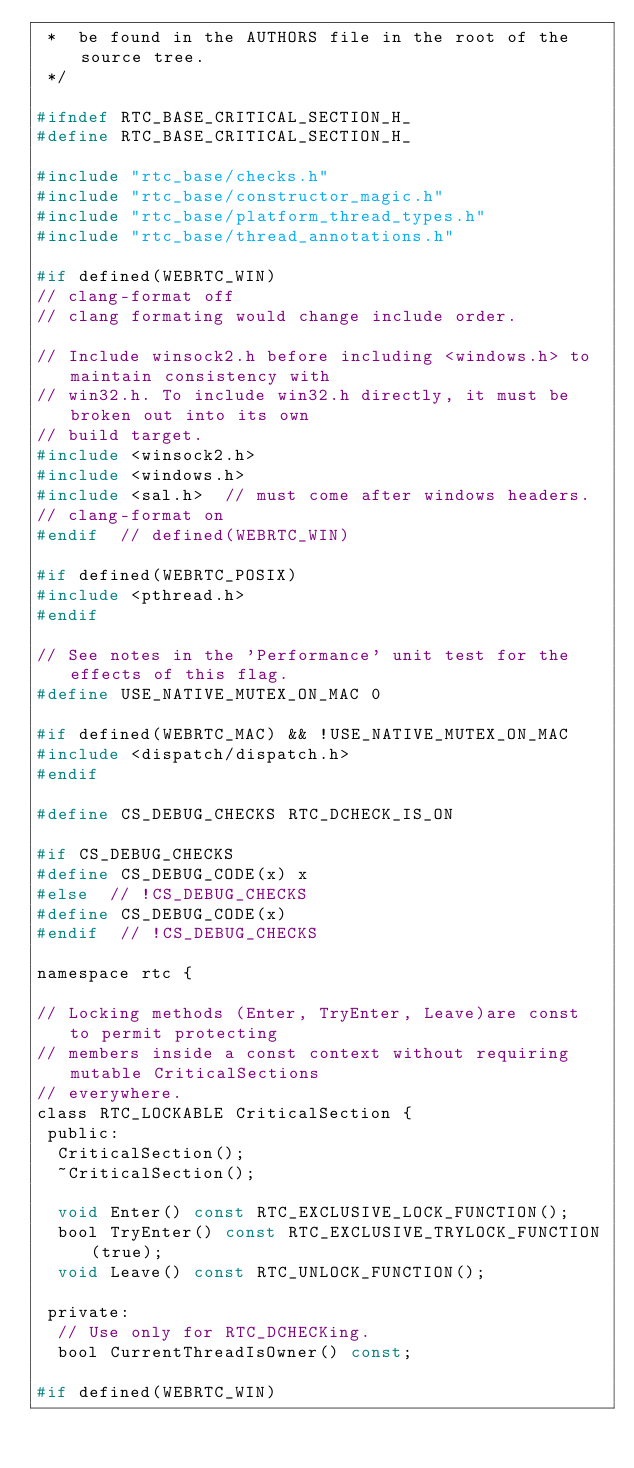<code> <loc_0><loc_0><loc_500><loc_500><_C_> *  be found in the AUTHORS file in the root of the source tree.
 */

#ifndef RTC_BASE_CRITICAL_SECTION_H_
#define RTC_BASE_CRITICAL_SECTION_H_

#include "rtc_base/checks.h"
#include "rtc_base/constructor_magic.h"
#include "rtc_base/platform_thread_types.h"
#include "rtc_base/thread_annotations.h"

#if defined(WEBRTC_WIN)
// clang-format off
// clang formating would change include order.

// Include winsock2.h before including <windows.h> to maintain consistency with
// win32.h. To include win32.h directly, it must be broken out into its own
// build target.
#include <winsock2.h>
#include <windows.h>
#include <sal.h>  // must come after windows headers.
// clang-format on
#endif  // defined(WEBRTC_WIN)

#if defined(WEBRTC_POSIX)
#include <pthread.h>
#endif

// See notes in the 'Performance' unit test for the effects of this flag.
#define USE_NATIVE_MUTEX_ON_MAC 0

#if defined(WEBRTC_MAC) && !USE_NATIVE_MUTEX_ON_MAC
#include <dispatch/dispatch.h>
#endif

#define CS_DEBUG_CHECKS RTC_DCHECK_IS_ON

#if CS_DEBUG_CHECKS
#define CS_DEBUG_CODE(x) x
#else  // !CS_DEBUG_CHECKS
#define CS_DEBUG_CODE(x)
#endif  // !CS_DEBUG_CHECKS

namespace rtc {

// Locking methods (Enter, TryEnter, Leave)are const to permit protecting
// members inside a const context without requiring mutable CriticalSections
// everywhere.
class RTC_LOCKABLE CriticalSection {
 public:
  CriticalSection();
  ~CriticalSection();

  void Enter() const RTC_EXCLUSIVE_LOCK_FUNCTION();
  bool TryEnter() const RTC_EXCLUSIVE_TRYLOCK_FUNCTION(true);
  void Leave() const RTC_UNLOCK_FUNCTION();

 private:
  // Use only for RTC_DCHECKing.
  bool CurrentThreadIsOwner() const;

#if defined(WEBRTC_WIN)</code> 